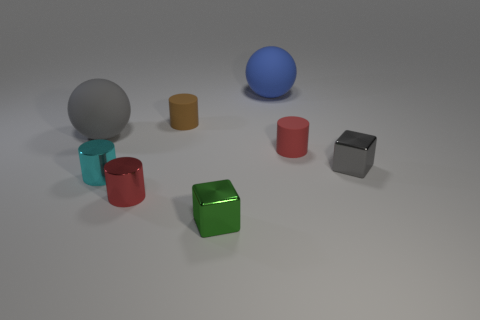Add 1 small blue shiny cubes. How many objects exist? 9 Subtract all cubes. How many objects are left? 6 Subtract 0 green spheres. How many objects are left? 8 Subtract all metallic objects. Subtract all large blue spheres. How many objects are left? 3 Add 6 red matte cylinders. How many red matte cylinders are left? 7 Add 2 large gray matte things. How many large gray matte things exist? 3 